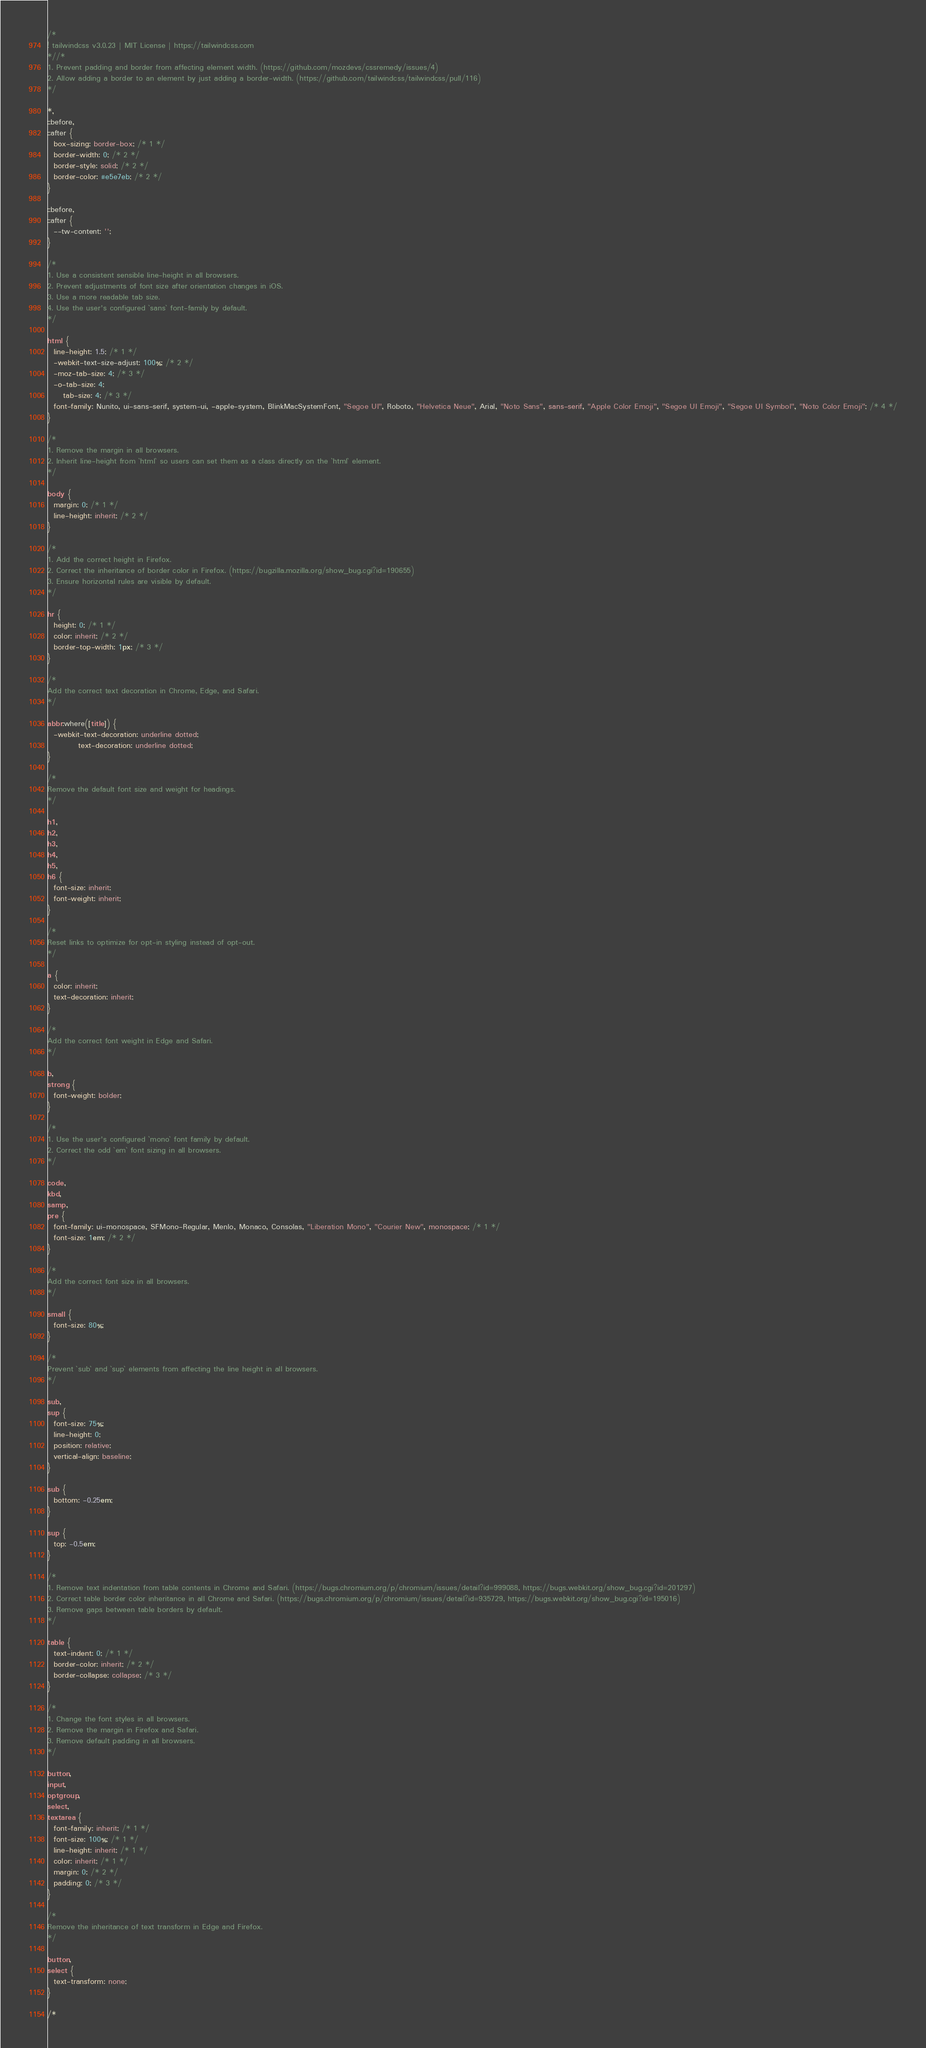Convert code to text. <code><loc_0><loc_0><loc_500><loc_500><_CSS_>/*
! tailwindcss v3.0.23 | MIT License | https://tailwindcss.com
*//*
1. Prevent padding and border from affecting element width. (https://github.com/mozdevs/cssremedy/issues/4)
2. Allow adding a border to an element by just adding a border-width. (https://github.com/tailwindcss/tailwindcss/pull/116)
*/

*,
::before,
::after {
  box-sizing: border-box; /* 1 */
  border-width: 0; /* 2 */
  border-style: solid; /* 2 */
  border-color: #e5e7eb; /* 2 */
}

::before,
::after {
  --tw-content: '';
}

/*
1. Use a consistent sensible line-height in all browsers.
2. Prevent adjustments of font size after orientation changes in iOS.
3. Use a more readable tab size.
4. Use the user's configured `sans` font-family by default.
*/

html {
  line-height: 1.5; /* 1 */
  -webkit-text-size-adjust: 100%; /* 2 */
  -moz-tab-size: 4; /* 3 */
  -o-tab-size: 4;
     tab-size: 4; /* 3 */
  font-family: Nunito, ui-sans-serif, system-ui, -apple-system, BlinkMacSystemFont, "Segoe UI", Roboto, "Helvetica Neue", Arial, "Noto Sans", sans-serif, "Apple Color Emoji", "Segoe UI Emoji", "Segoe UI Symbol", "Noto Color Emoji"; /* 4 */
}

/*
1. Remove the margin in all browsers.
2. Inherit line-height from `html` so users can set them as a class directly on the `html` element.
*/

body {
  margin: 0; /* 1 */
  line-height: inherit; /* 2 */
}

/*
1. Add the correct height in Firefox.
2. Correct the inheritance of border color in Firefox. (https://bugzilla.mozilla.org/show_bug.cgi?id=190655)
3. Ensure horizontal rules are visible by default.
*/

hr {
  height: 0; /* 1 */
  color: inherit; /* 2 */
  border-top-width: 1px; /* 3 */
}

/*
Add the correct text decoration in Chrome, Edge, and Safari.
*/

abbr:where([title]) {
  -webkit-text-decoration: underline dotted;
          text-decoration: underline dotted;
}

/*
Remove the default font size and weight for headings.
*/

h1,
h2,
h3,
h4,
h5,
h6 {
  font-size: inherit;
  font-weight: inherit;
}

/*
Reset links to optimize for opt-in styling instead of opt-out.
*/

a {
  color: inherit;
  text-decoration: inherit;
}

/*
Add the correct font weight in Edge and Safari.
*/

b,
strong {
  font-weight: bolder;
}

/*
1. Use the user's configured `mono` font family by default.
2. Correct the odd `em` font sizing in all browsers.
*/

code,
kbd,
samp,
pre {
  font-family: ui-monospace, SFMono-Regular, Menlo, Monaco, Consolas, "Liberation Mono", "Courier New", monospace; /* 1 */
  font-size: 1em; /* 2 */
}

/*
Add the correct font size in all browsers.
*/

small {
  font-size: 80%;
}

/*
Prevent `sub` and `sup` elements from affecting the line height in all browsers.
*/

sub,
sup {
  font-size: 75%;
  line-height: 0;
  position: relative;
  vertical-align: baseline;
}

sub {
  bottom: -0.25em;
}

sup {
  top: -0.5em;
}

/*
1. Remove text indentation from table contents in Chrome and Safari. (https://bugs.chromium.org/p/chromium/issues/detail?id=999088, https://bugs.webkit.org/show_bug.cgi?id=201297)
2. Correct table border color inheritance in all Chrome and Safari. (https://bugs.chromium.org/p/chromium/issues/detail?id=935729, https://bugs.webkit.org/show_bug.cgi?id=195016)
3. Remove gaps between table borders by default.
*/

table {
  text-indent: 0; /* 1 */
  border-color: inherit; /* 2 */
  border-collapse: collapse; /* 3 */
}

/*
1. Change the font styles in all browsers.
2. Remove the margin in Firefox and Safari.
3. Remove default padding in all browsers.
*/

button,
input,
optgroup,
select,
textarea {
  font-family: inherit; /* 1 */
  font-size: 100%; /* 1 */
  line-height: inherit; /* 1 */
  color: inherit; /* 1 */
  margin: 0; /* 2 */
  padding: 0; /* 3 */
}

/*
Remove the inheritance of text transform in Edge and Firefox.
*/

button,
select {
  text-transform: none;
}

/*</code> 